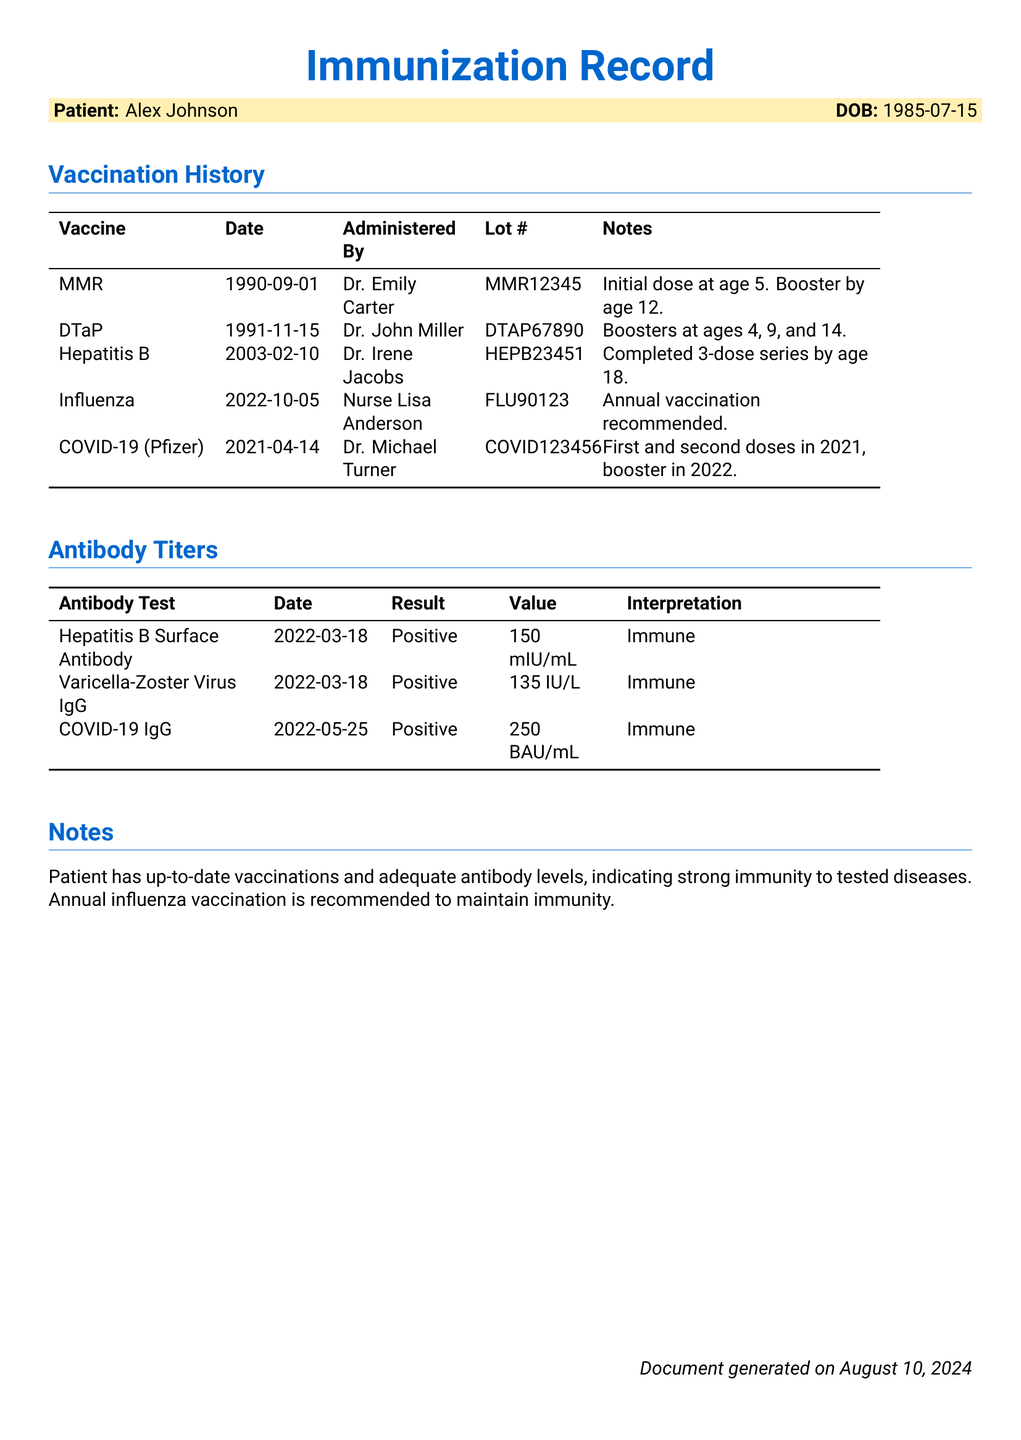What is the patient's name? The patient's name is listed at the top of the document under the patient information section.
Answer: Alex Johnson When was the last influenza vaccination administered? The date for the last influenza vaccination can be found in the vaccination history table.
Answer: 2022-10-05 What is the lot number for the COVID-19 vaccine? The lot number for the COVID-19 vaccine is provided in the vaccination history table.
Answer: COVID123456 Is the Hepatitis B surface antibody result positive or negative? This result is indicated in the antibody titers section of the document.
Answer: Positive What does the interpretation of the COVID-19 IgG test indicate? The interpretation column provides insight into the result of the antibody test.
Answer: Immune How many doses were completed for the Hepatitis B vaccine series? This information is included in the notes of the vaccination history section.
Answer: 3-dose series What is recommended annually according to the notes? The notes section suggests a specific vaccination based on immunization status.
Answer: Influenza vaccination What age was the patient when they received the MMR vaccine? The age can be calculated from the administration date and the patient’s birth date.
Answer: 5 years What was the value of the Varicella-Zoster Virus IgG test? The value is directly listed in the antibody titers section of the document.
Answer: 135 IU/L 